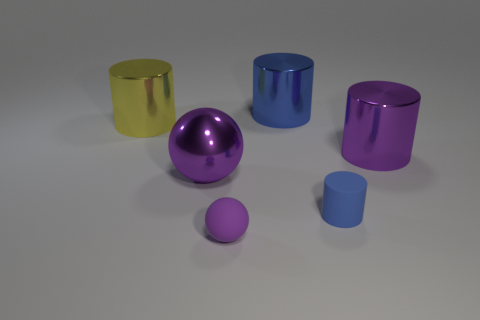There is a matte thing that is the same color as the metal ball; what size is it?
Your response must be concise. Small. What is the shape of the metal object that is the same color as the large ball?
Provide a short and direct response. Cylinder. Is there a object made of the same material as the tiny sphere?
Offer a terse response. Yes. Does the purple metal object to the right of the tiny purple matte sphere have the same shape as the tiny purple rubber object?
Offer a very short reply. No. How many tiny purple matte objects are behind the blue cylinder in front of the big purple thing right of the big blue thing?
Offer a very short reply. 0. Are there fewer cylinders that are right of the blue metal cylinder than objects to the right of the yellow metal cylinder?
Ensure brevity in your answer.  Yes. What is the color of the rubber thing that is the same shape as the yellow shiny object?
Your answer should be compact. Blue. What size is the yellow cylinder?
Provide a short and direct response. Large. How many purple cylinders are the same size as the blue metallic thing?
Provide a short and direct response. 1. Is the color of the large shiny sphere the same as the matte sphere?
Your answer should be very brief. Yes. 